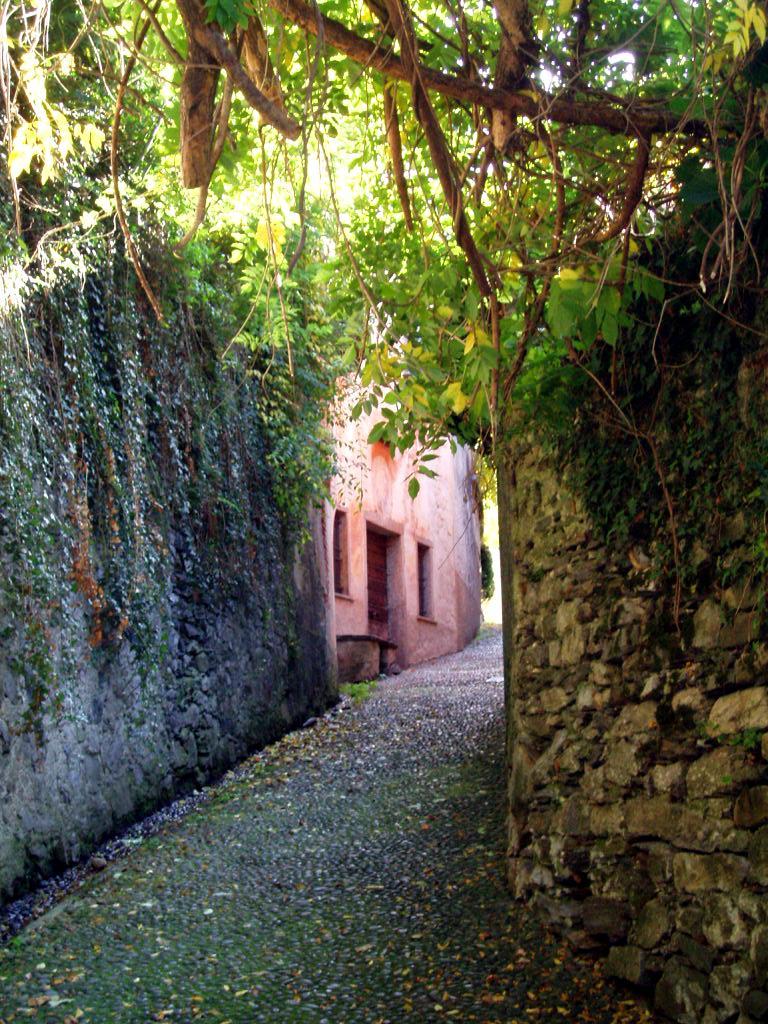How would you summarize this image in a sentence or two? In this picture we can see wall, house, and trees. 